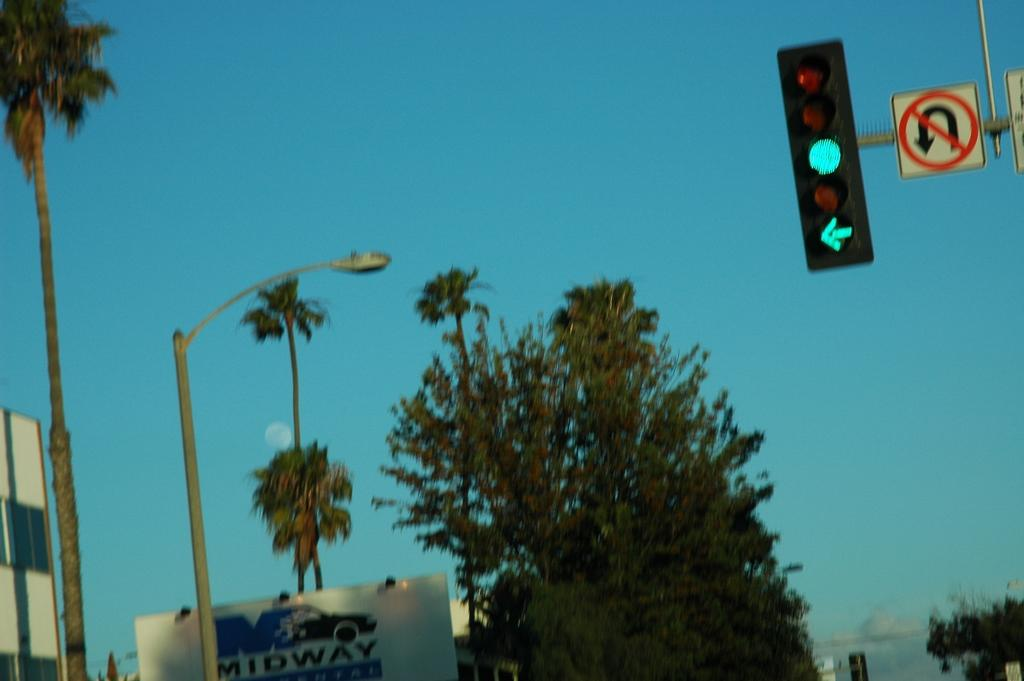Provide a one-sentence caption for the provided image. a green traffic light with a sign saying not to do u-turns. 